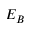<formula> <loc_0><loc_0><loc_500><loc_500>E _ { B }</formula> 